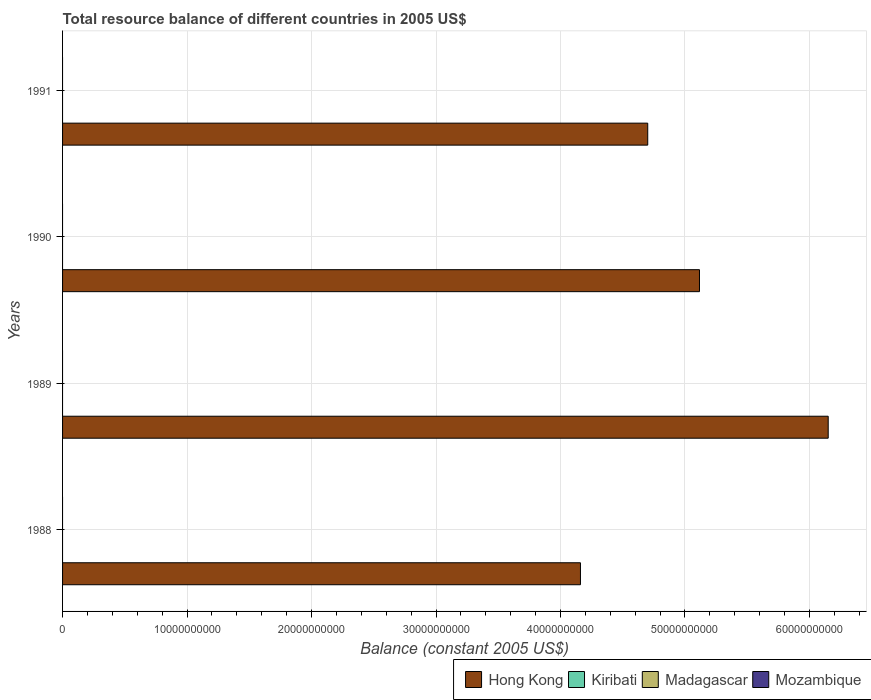Are the number of bars on each tick of the Y-axis equal?
Offer a terse response. Yes. How many bars are there on the 3rd tick from the top?
Give a very brief answer. 1. What is the label of the 2nd group of bars from the top?
Offer a terse response. 1990. What is the total resource balance in Hong Kong in 1988?
Provide a succinct answer. 4.16e+1. Across all years, what is the maximum total resource balance in Hong Kong?
Give a very brief answer. 6.15e+1. What is the total total resource balance in Hong Kong in the graph?
Offer a terse response. 2.01e+11. What is the difference between the total resource balance in Hong Kong in 1988 and that in 1990?
Your answer should be compact. -9.56e+09. What is the difference between the total resource balance in Mozambique in 1990 and the total resource balance in Hong Kong in 1989?
Make the answer very short. -6.15e+1. What is the average total resource balance in Hong Kong per year?
Ensure brevity in your answer.  5.03e+1. In how many years, is the total resource balance in Kiribati greater than 32000000000 US$?
Ensure brevity in your answer.  0. What is the difference between the highest and the lowest total resource balance in Hong Kong?
Provide a succinct answer. 1.99e+1. How many years are there in the graph?
Your answer should be very brief. 4. What is the difference between two consecutive major ticks on the X-axis?
Provide a succinct answer. 1.00e+1. Are the values on the major ticks of X-axis written in scientific E-notation?
Offer a terse response. No. Does the graph contain any zero values?
Your answer should be very brief. Yes. Does the graph contain grids?
Ensure brevity in your answer.  Yes. What is the title of the graph?
Ensure brevity in your answer.  Total resource balance of different countries in 2005 US$. What is the label or title of the X-axis?
Provide a succinct answer. Balance (constant 2005 US$). What is the Balance (constant 2005 US$) in Hong Kong in 1988?
Your answer should be very brief. 4.16e+1. What is the Balance (constant 2005 US$) of Madagascar in 1988?
Your response must be concise. 0. What is the Balance (constant 2005 US$) of Hong Kong in 1989?
Keep it short and to the point. 6.15e+1. What is the Balance (constant 2005 US$) in Kiribati in 1989?
Ensure brevity in your answer.  0. What is the Balance (constant 2005 US$) in Madagascar in 1989?
Your answer should be very brief. 0. What is the Balance (constant 2005 US$) in Mozambique in 1989?
Offer a very short reply. 0. What is the Balance (constant 2005 US$) in Hong Kong in 1990?
Make the answer very short. 5.12e+1. What is the Balance (constant 2005 US$) in Madagascar in 1990?
Offer a very short reply. 0. What is the Balance (constant 2005 US$) in Hong Kong in 1991?
Make the answer very short. 4.70e+1. What is the Balance (constant 2005 US$) of Kiribati in 1991?
Offer a very short reply. 0. Across all years, what is the maximum Balance (constant 2005 US$) of Hong Kong?
Offer a very short reply. 6.15e+1. Across all years, what is the minimum Balance (constant 2005 US$) in Hong Kong?
Provide a short and direct response. 4.16e+1. What is the total Balance (constant 2005 US$) of Hong Kong in the graph?
Provide a succinct answer. 2.01e+11. What is the total Balance (constant 2005 US$) in Kiribati in the graph?
Offer a terse response. 0. What is the difference between the Balance (constant 2005 US$) of Hong Kong in 1988 and that in 1989?
Your answer should be compact. -1.99e+1. What is the difference between the Balance (constant 2005 US$) of Hong Kong in 1988 and that in 1990?
Give a very brief answer. -9.56e+09. What is the difference between the Balance (constant 2005 US$) in Hong Kong in 1988 and that in 1991?
Ensure brevity in your answer.  -5.40e+09. What is the difference between the Balance (constant 2005 US$) in Hong Kong in 1989 and that in 1990?
Your answer should be compact. 1.03e+1. What is the difference between the Balance (constant 2005 US$) in Hong Kong in 1989 and that in 1991?
Make the answer very short. 1.45e+1. What is the difference between the Balance (constant 2005 US$) in Hong Kong in 1990 and that in 1991?
Give a very brief answer. 4.16e+09. What is the average Balance (constant 2005 US$) in Hong Kong per year?
Give a very brief answer. 5.03e+1. What is the average Balance (constant 2005 US$) of Kiribati per year?
Make the answer very short. 0. What is the average Balance (constant 2005 US$) of Madagascar per year?
Offer a terse response. 0. What is the ratio of the Balance (constant 2005 US$) of Hong Kong in 1988 to that in 1989?
Your answer should be compact. 0.68. What is the ratio of the Balance (constant 2005 US$) of Hong Kong in 1988 to that in 1990?
Keep it short and to the point. 0.81. What is the ratio of the Balance (constant 2005 US$) in Hong Kong in 1988 to that in 1991?
Make the answer very short. 0.89. What is the ratio of the Balance (constant 2005 US$) of Hong Kong in 1989 to that in 1990?
Your answer should be very brief. 1.2. What is the ratio of the Balance (constant 2005 US$) of Hong Kong in 1989 to that in 1991?
Offer a terse response. 1.31. What is the ratio of the Balance (constant 2005 US$) of Hong Kong in 1990 to that in 1991?
Keep it short and to the point. 1.09. What is the difference between the highest and the second highest Balance (constant 2005 US$) of Hong Kong?
Provide a succinct answer. 1.03e+1. What is the difference between the highest and the lowest Balance (constant 2005 US$) of Hong Kong?
Ensure brevity in your answer.  1.99e+1. 